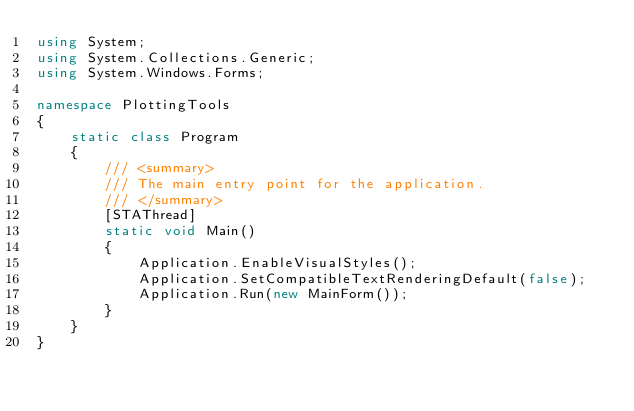<code> <loc_0><loc_0><loc_500><loc_500><_C#_>using System;
using System.Collections.Generic;
using System.Windows.Forms;

namespace PlottingTools
{
    static class Program
    {
        /// <summary>
        /// The main entry point for the application.
        /// </summary>
        [STAThread]
        static void Main()
        {
            Application.EnableVisualStyles();
            Application.SetCompatibleTextRenderingDefault(false);
            Application.Run(new MainForm());
        }
    }
}</code> 